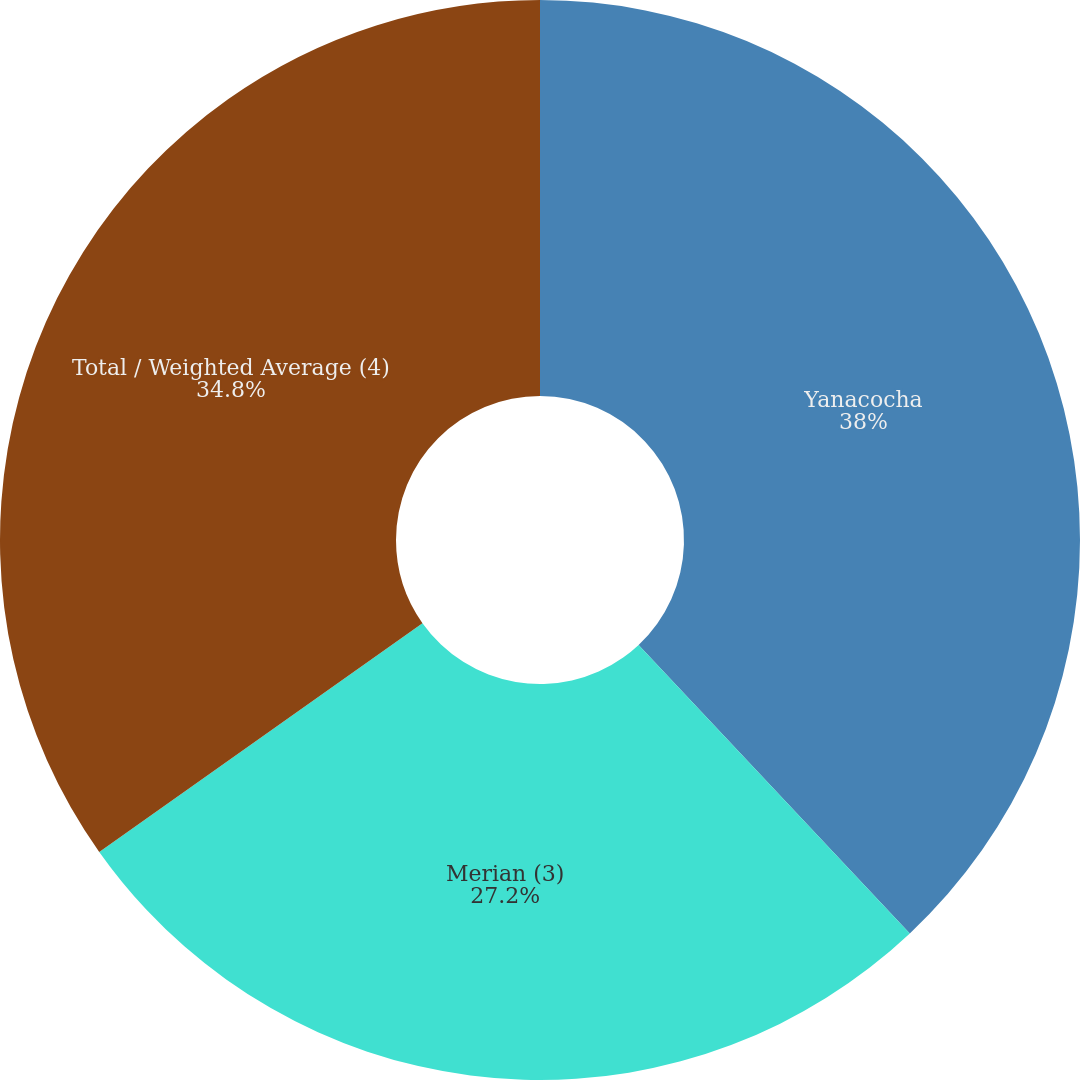Convert chart. <chart><loc_0><loc_0><loc_500><loc_500><pie_chart><fcel>Yanacocha<fcel>Merian (3)<fcel>Total / Weighted Average (4)<nl><fcel>37.99%<fcel>27.2%<fcel>34.8%<nl></chart> 